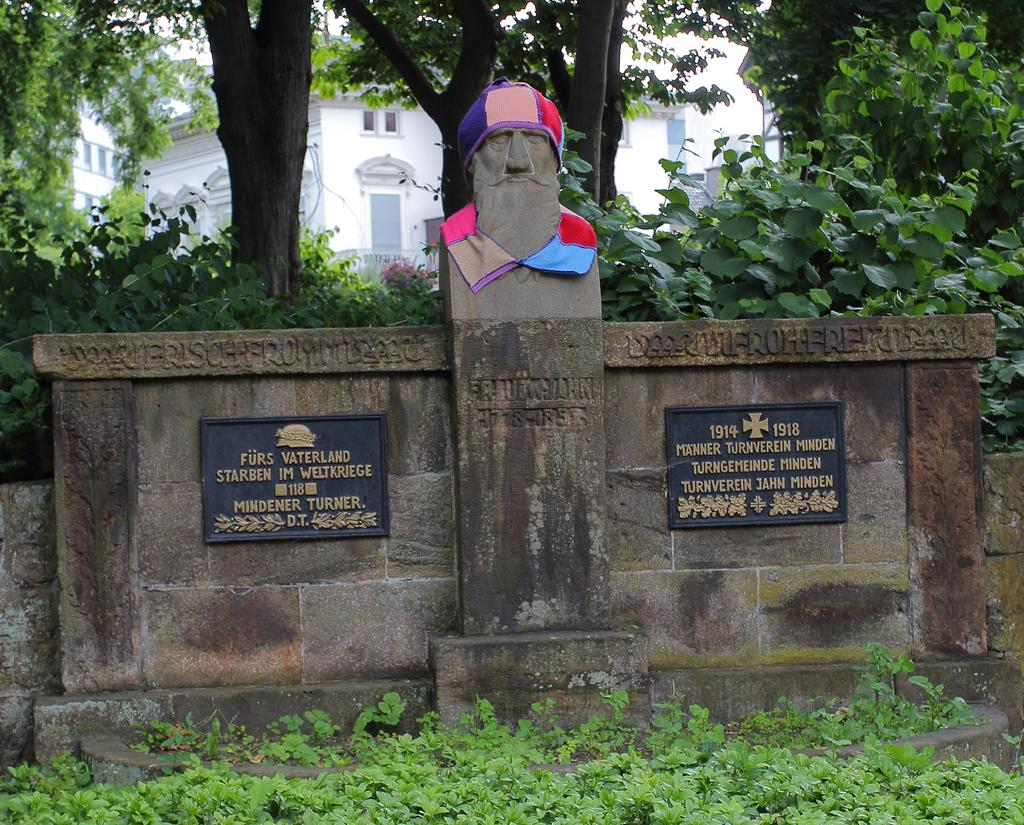What is the main subject in the center of the image? There is a stone, a sculpture, and banners in the center of the image. Can you describe the stone in the image? The stone is in the center of the image. What can be seen in the background of the image? There are buildings, trees, and plants visible in the background of the image. What type of vegetation is at the bottom of the image? Grass is visible at the bottom of the image. What type of whistle can be heard coming from the cave in the image? There is no cave present in the image, so it's not possible to determine if a whistle can be heard. How much salt is visible on the stone in the image? There is no salt visible on the stone in the image. 